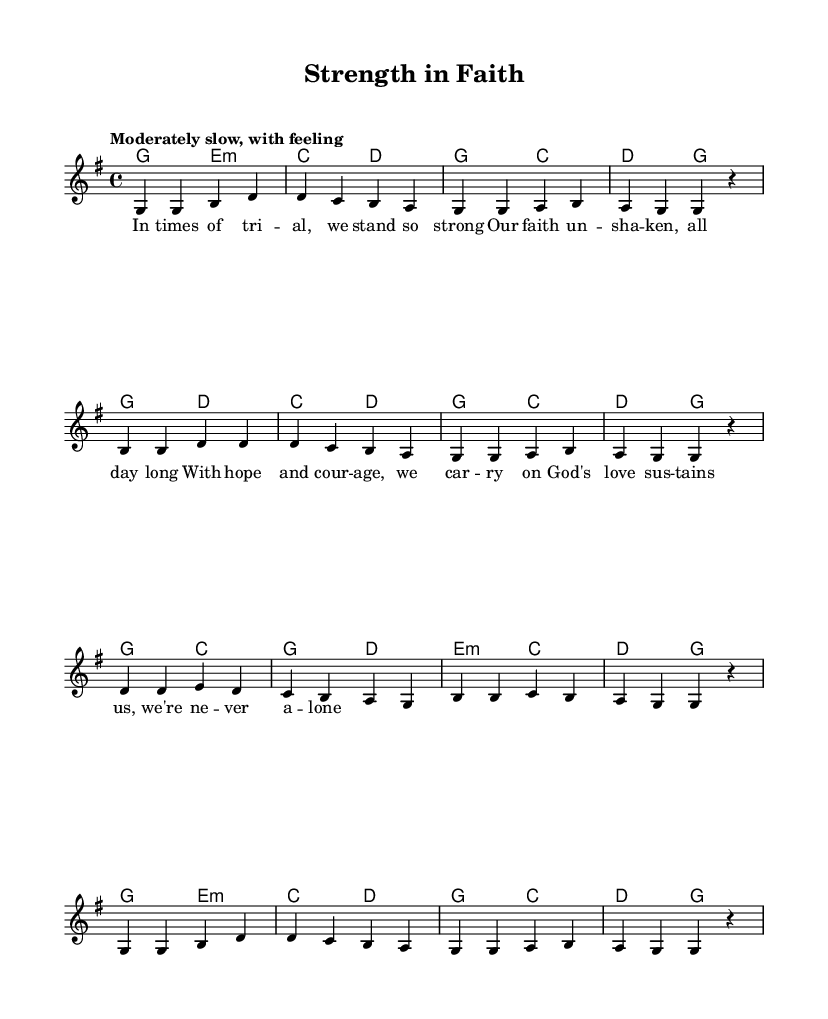What is the key signature of this music? The key signature is G major, which has one sharp (F#). This can be determined by looking at the key signature indicated at the beginning of the score.
Answer: G major What is the time signature of this piece? The time signature is 4/4, which is indicated at the beginning of the score next to the key signature. This means there are four beats per measure.
Answer: 4/4 What is the tempo marking of this hymn? The tempo marking is "Moderately slow, with feeling." This is specified near the start of the score to guide the performer on the speed and emotional delivery of the piece.
Answer: Moderately slow, with feeling How many measures are in the first section of the piece? The first section includes eight measures, indicated by counting the vertical lines that separate the individual measures in the sheet music.
Answer: 8 What is the focus of the lyrics in this hymn? The lyrics emphasize resilience and faith in times of trial, as seen in the text that highlights strength, unwavering faith, and God’s sustaining love. This aligns with the uplifting theme of gospel hymns.
Answer: Resilience and faith How does the harmony complement the melody in this hymn? The harmony supports the melody through chord progressions that align with the melody notes. By analyzing the chords played alongside the melody, one can see they enhance emotional depth and emphasize the themes found in the lyrics, such as strength in faith.
Answer: Enhances emotional depth What is the emotional message conveyed by the lyrics in this piece? The lyrics convey a message of hope and encouragement, emphasizing unity and support through faith. Analyzing words such as “strength,” “courage,” and “never alone” reveals the uplifting and supportive intent behind the hymn.
Answer: Hope and encouragement 